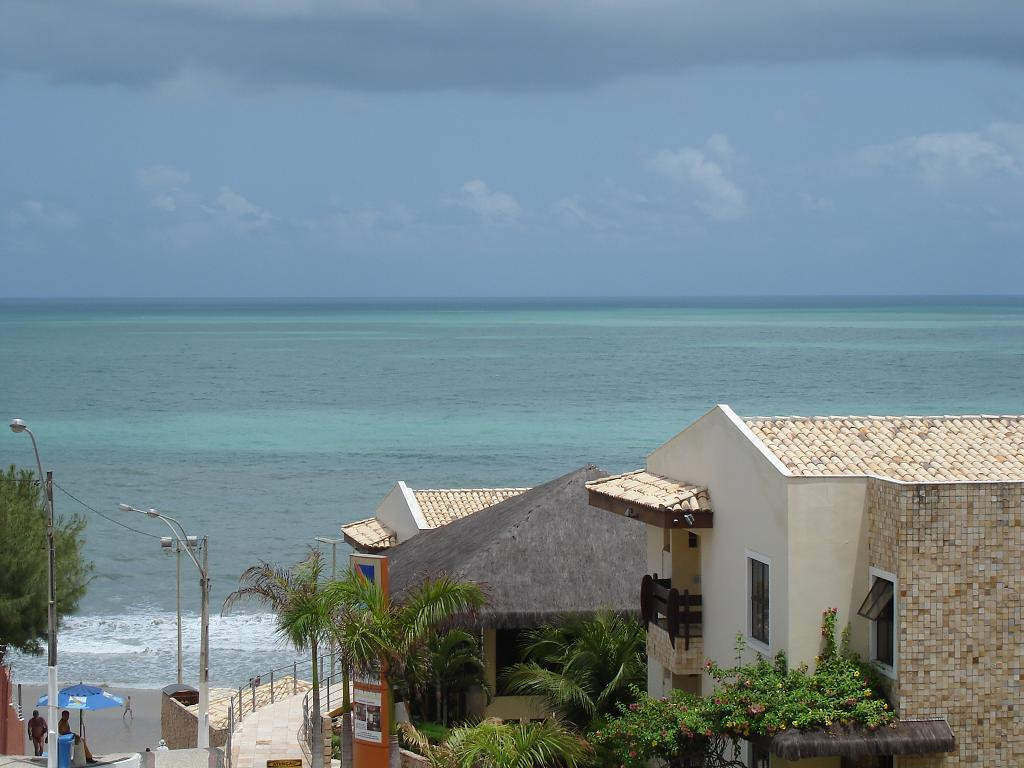What type of structures can be seen in the image? There are buildings in the image. What other natural elements are present in the image? There are trees in the image. Are there any man-made objects that provide illumination? Yes, there are light poles in the image. What object is used for protection from the rain in the image? There is an umbrella in the image. Can you identify any living beings in the image? Yes, there are people in the image. What can be seen in the background of the image? The sky is visible in the background of the image. Are there any barriers or safety features in the image? Yes, there are railings in front of the building. How many lawyers are present in the image? There is no mention of lawyers in the image, so it is impossible to determine their presence or number. What type of partner is associated with the building in the image? There is no mention of a partner or any partnership related to the building in the image. 